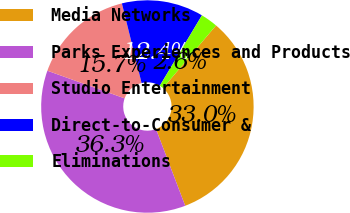Convert chart. <chart><loc_0><loc_0><loc_500><loc_500><pie_chart><fcel>Media Networks<fcel>Parks Experiences and Products<fcel>Studio Entertainment<fcel>Direct-to-Consumer &<fcel>Eliminations<nl><fcel>33.03%<fcel>36.26%<fcel>15.67%<fcel>12.44%<fcel>2.6%<nl></chart> 